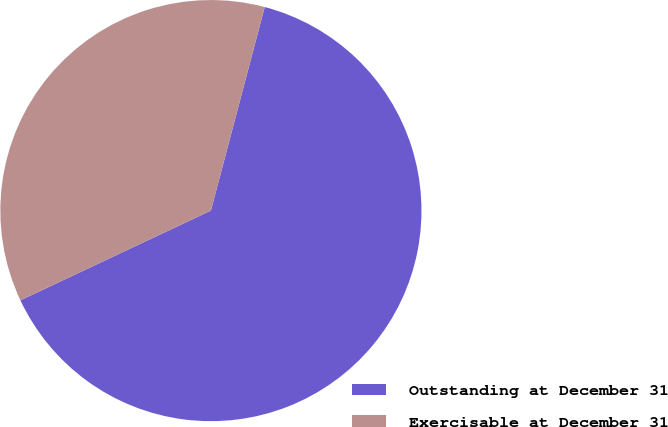Convert chart to OTSL. <chart><loc_0><loc_0><loc_500><loc_500><pie_chart><fcel>Outstanding at December 31<fcel>Exercisable at December 31<nl><fcel>63.88%<fcel>36.12%<nl></chart> 